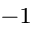Convert formula to latex. <formula><loc_0><loc_0><loc_500><loc_500>^ { - 1 }</formula> 